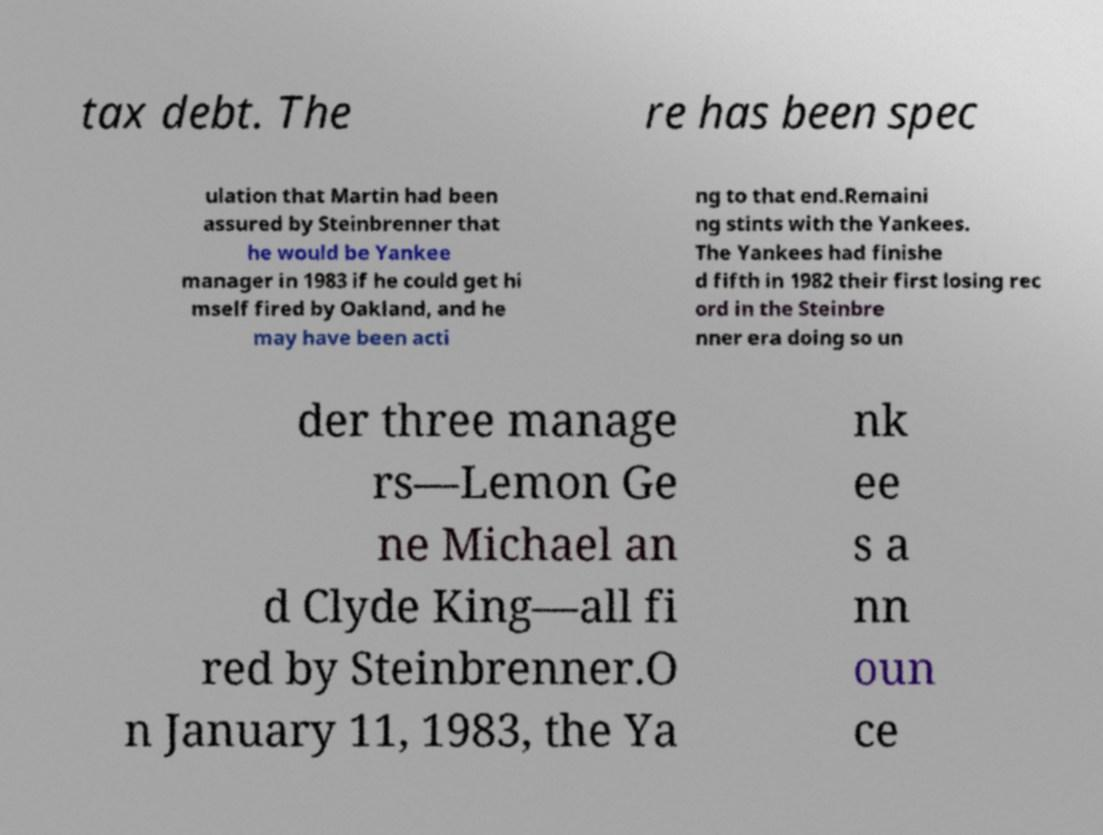Could you extract and type out the text from this image? tax debt. The re has been spec ulation that Martin had been assured by Steinbrenner that he would be Yankee manager in 1983 if he could get hi mself fired by Oakland, and he may have been acti ng to that end.Remaini ng stints with the Yankees. The Yankees had finishe d fifth in 1982 their first losing rec ord in the Steinbre nner era doing so un der three manage rs—Lemon Ge ne Michael an d Clyde King—all fi red by Steinbrenner.O n January 11, 1983, the Ya nk ee s a nn oun ce 